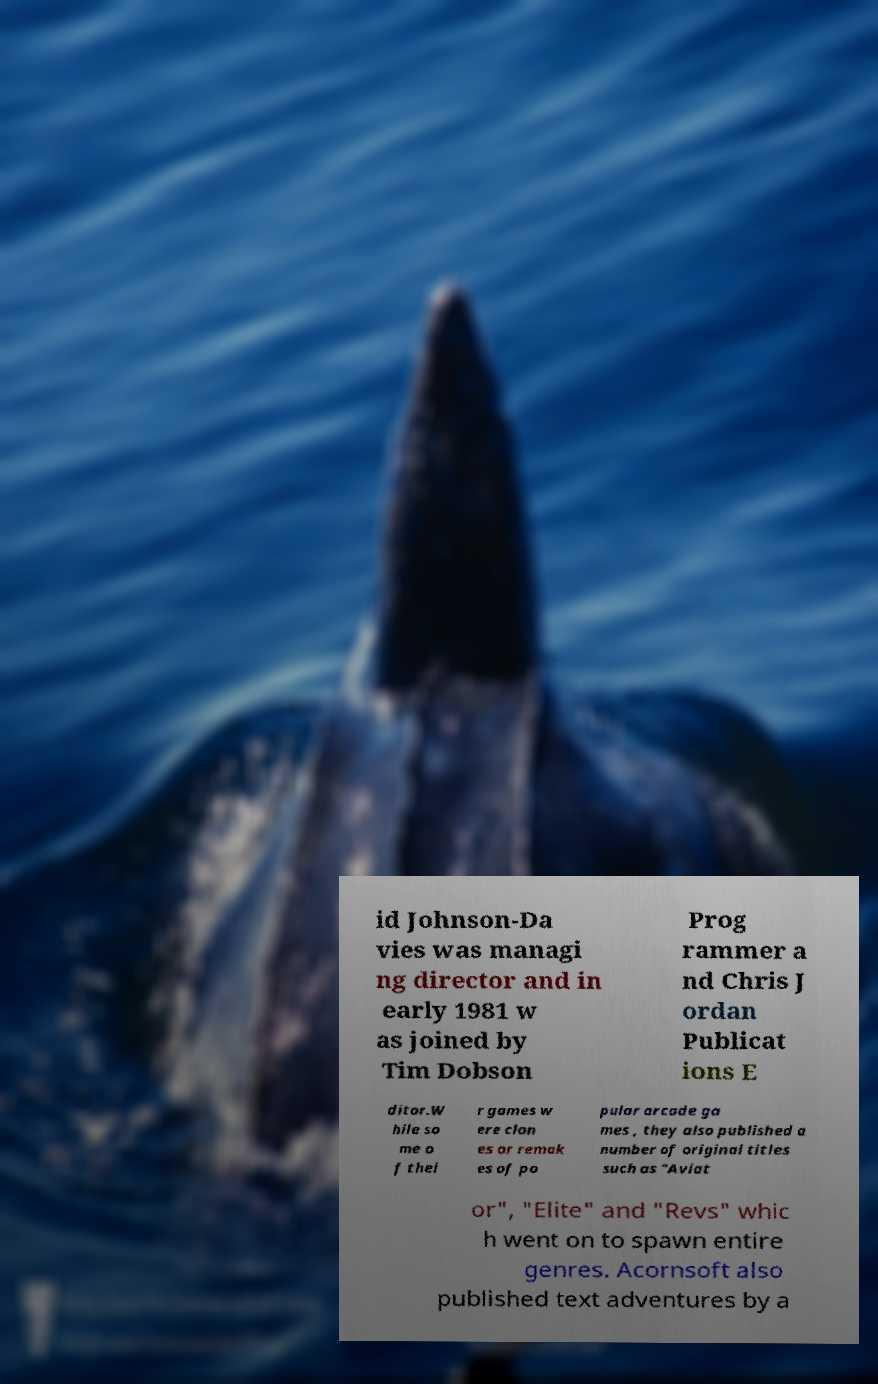Please read and relay the text visible in this image. What does it say? id Johnson-Da vies was managi ng director and in early 1981 w as joined by Tim Dobson Prog rammer a nd Chris J ordan Publicat ions E ditor.W hile so me o f thei r games w ere clon es or remak es of po pular arcade ga mes , they also published a number of original titles such as "Aviat or", "Elite" and "Revs" whic h went on to spawn entire genres. Acornsoft also published text adventures by a 